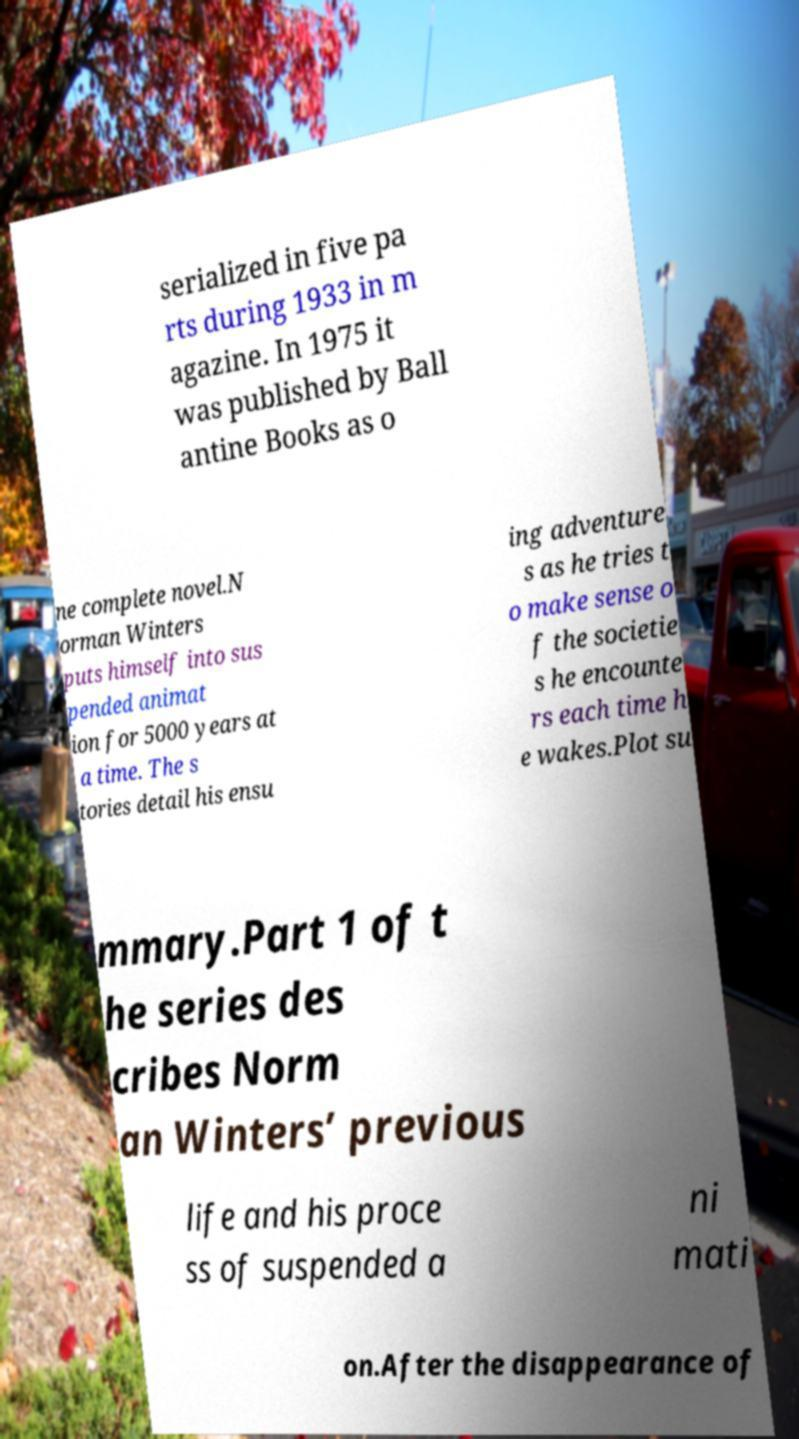There's text embedded in this image that I need extracted. Can you transcribe it verbatim? serialized in five pa rts during 1933 in m agazine. In 1975 it was published by Ball antine Books as o ne complete novel.N orman Winters puts himself into sus pended animat ion for 5000 years at a time. The s tories detail his ensu ing adventure s as he tries t o make sense o f the societie s he encounte rs each time h e wakes.Plot su mmary.Part 1 of t he series des cribes Norm an Winters’ previous life and his proce ss of suspended a ni mati on.After the disappearance of 